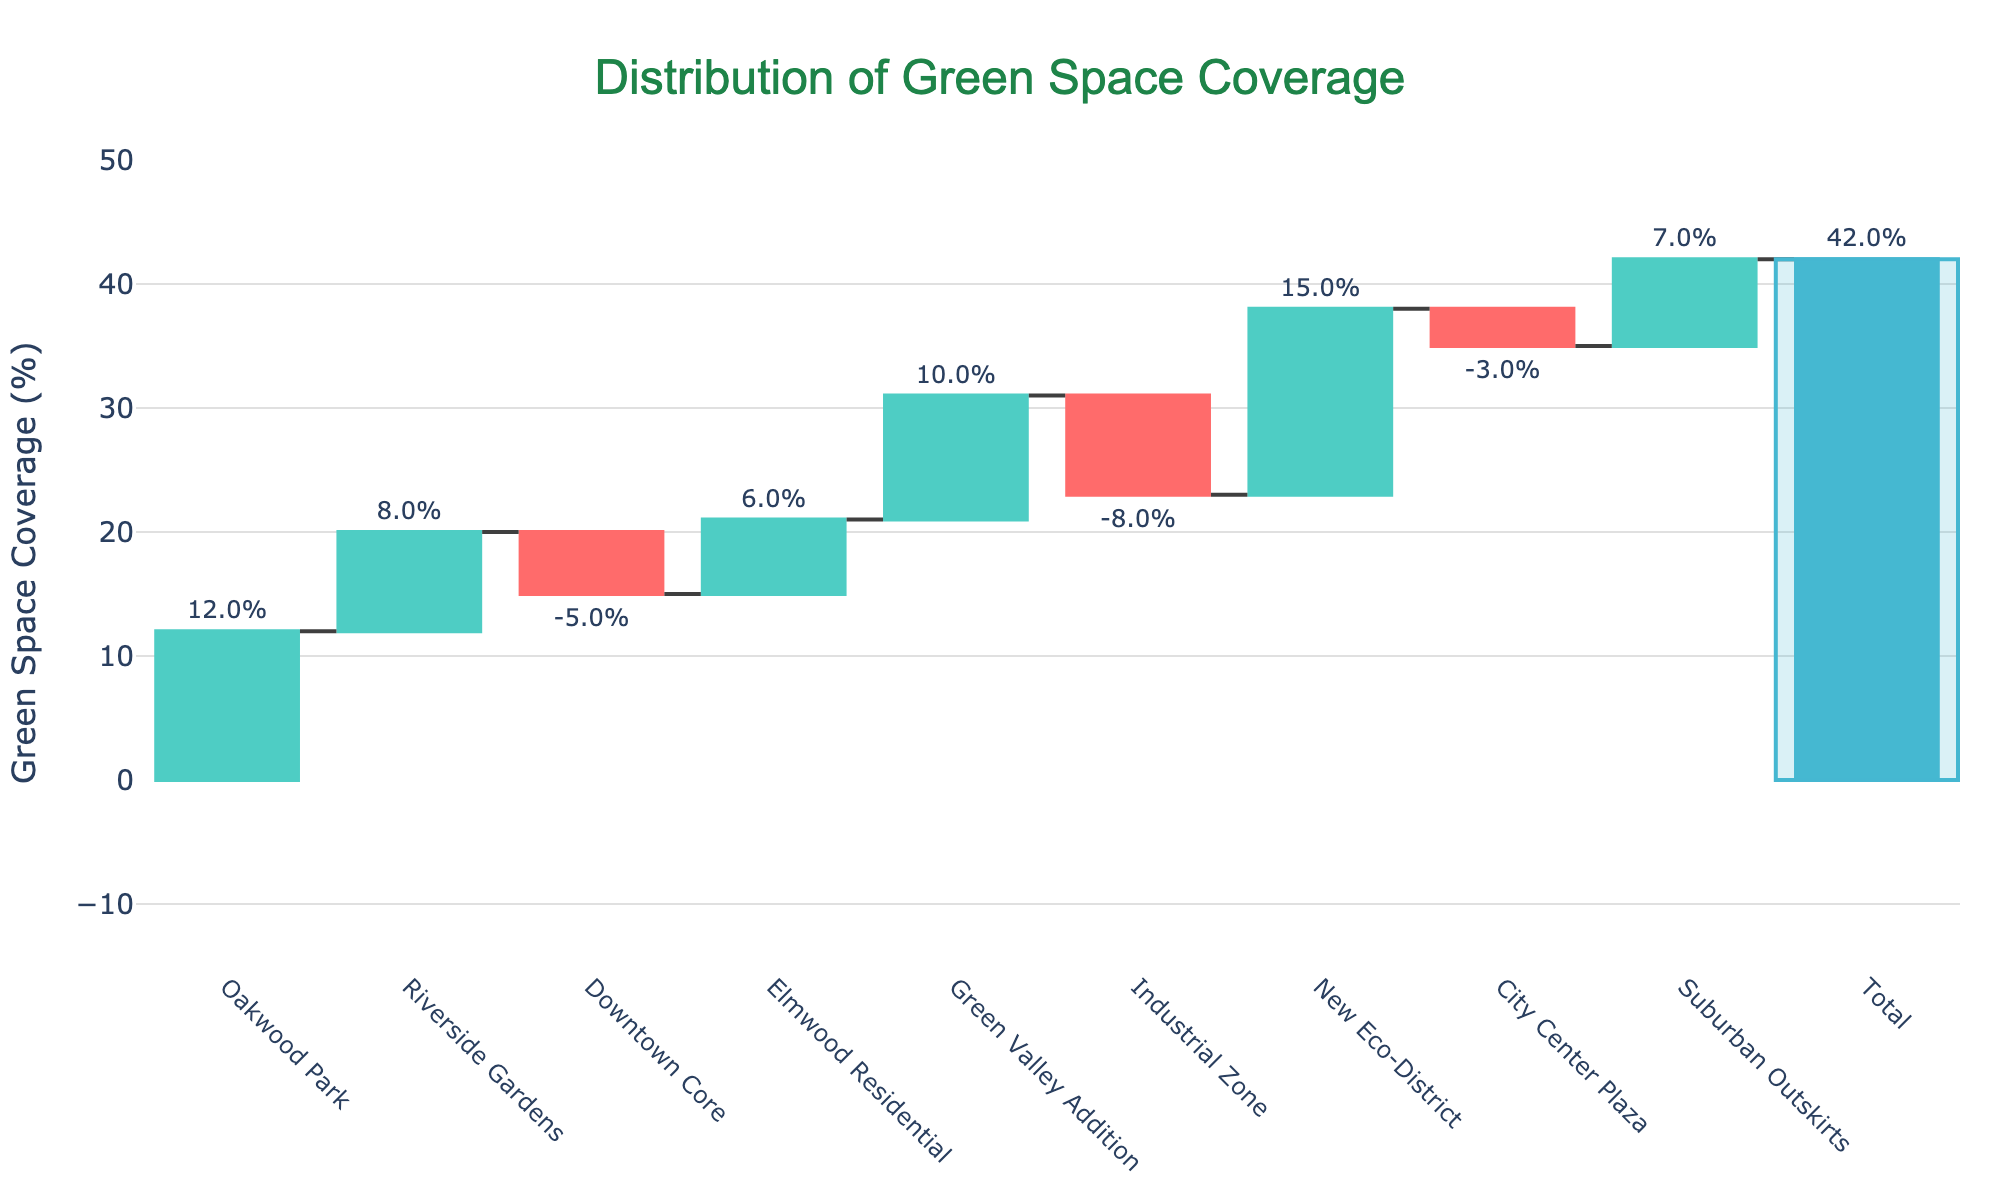What's the total green space coverage percentage shown in the chart? The title of the chart indicates "Total" at the last bar, which shows the cumulative percentage of green space coverage across all areas. The bar labeled "Total" shows a coverage of 42%.
Answer: 42% Which area has the highest green space coverage percentage? By observing the height of the bars, the "New Eco-District" has the highest green space coverage. The bar representing this area reaches 15%.
Answer: New Eco-District Which two areas have negative green space coverage percentages and what are their values? By identifying the bars in red color which represent negative values, "Downtown Core" has -5% and "Industrial Zone" has -8%.
Answer: Downtown Core: -5%, Industrial Zone: -8% What is the combined green space coverage percentage added by "Oakwood Park" and "Elmwood Residential"? The bar labeled "Oakwood Park" shows 12% and "Elmwood Residential" shows 6%. Adding these two values: 12% + 6% = 18%.
Answer: 18% How does the coverage of "Suburban Outskirts" compare to "Riverside Gardens"? The bar for "Suburban Outskirts" shows a 7%, and "Riverside Gardens" shows 8%. Therefore, "Suburban Outskirts" has 1% less coverage compared to "Riverside Gardens".
Answer: 1% less Which area has a green space coverage percentage close to the mid-point of all coverage percentages excluding the Total? The areas sorted by coverage percentage are: Industrial Zone (-8%), Downtown Core (-5%), City Center Plaza (-3%), Riverside Gardens (8%), Suburban Outskirts (7%), Elmwood Residential (6%), Green Valley Addition (10%), Oakwood Park (12%), New Eco-District (15%). The middle value is "Suburban Outskirts" and "Riverside Gardens" are closest to the mid-point.
Answer: Suburban Outskirts and Riverside Gardens Explain the significance of the colored bars in the waterfall chart. Green bars represent areas with increasing (positive) green space coverage, red bars represent areas with decreasing (negative) coverage, and the blue bar represents the total green space coverage for the neighborhood. By looking at the bars' colors, we can quickly identify which areas contribute positively or negatively to the overall green space coverage.
Answer: Green: Positive, Red: Negative, Blue: Total How does "City Center Plaza" affect the overall green space coverage? The bar for "City Center Plaza" is red and represents a -3% green space coverage. This means it decreases the overall green space coverage by 3%.
Answer: Decreases by 3% What's the average green space coverage of all areas (excluding the Total)? To find the average, sum all the individual green space coverages and divide by the number of areas. (-5 - 8 - 3 + 15 + 7 + 8 + 6 + 10 + 12) = 42 / 9 = 4.67%.
Answer: 4.67% 